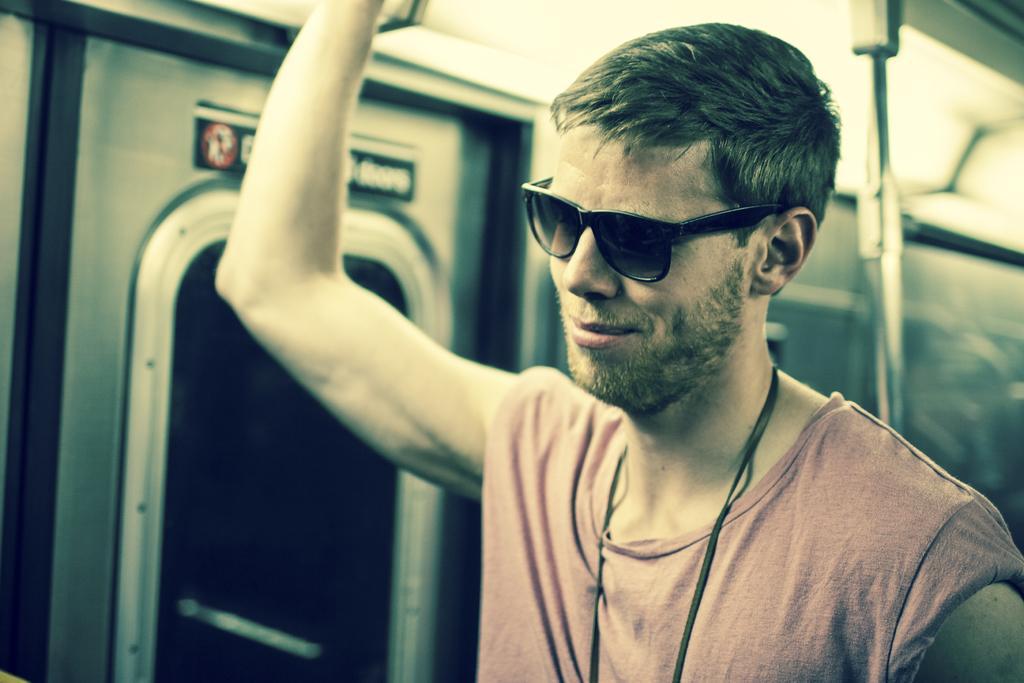Can you describe this image briefly? In this picture there is a person wearing goggles standing and there is a door beside him and there is a pole behind him. 